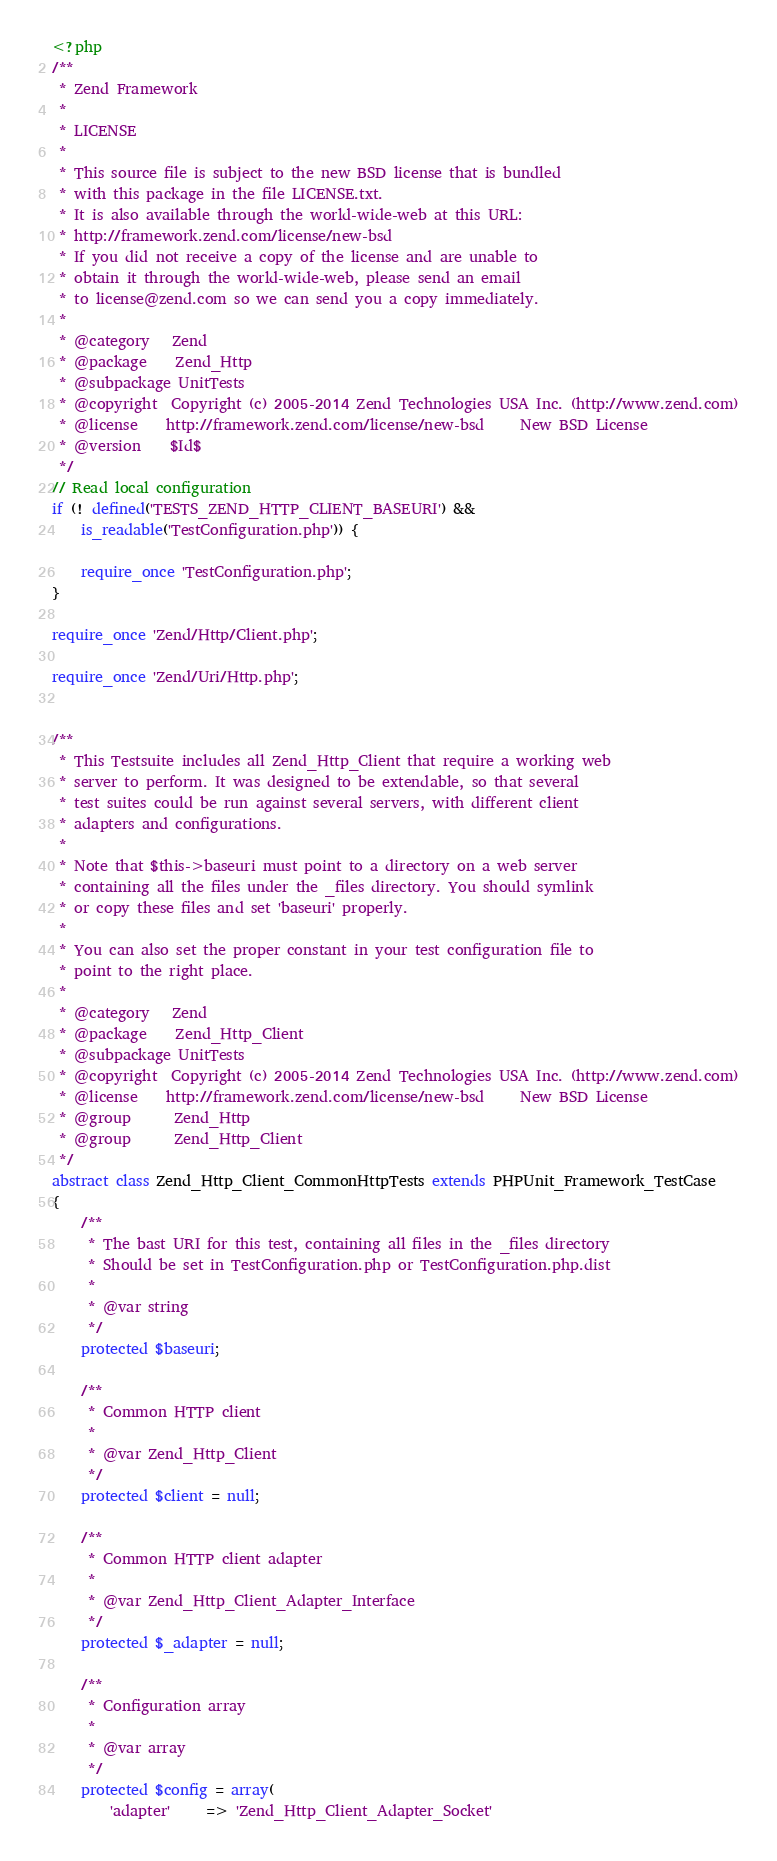Convert code to text. <code><loc_0><loc_0><loc_500><loc_500><_PHP_><?php
/**
 * Zend Framework
 *
 * LICENSE
 *
 * This source file is subject to the new BSD license that is bundled
 * with this package in the file LICENSE.txt.
 * It is also available through the world-wide-web at this URL:
 * http://framework.zend.com/license/new-bsd
 * If you did not receive a copy of the license and are unable to
 * obtain it through the world-wide-web, please send an email
 * to license@zend.com so we can send you a copy immediately.
 *
 * @category   Zend
 * @package    Zend_Http
 * @subpackage UnitTests
 * @copyright  Copyright (c) 2005-2014 Zend Technologies USA Inc. (http://www.zend.com)
 * @license    http://framework.zend.com/license/new-bsd     New BSD License
 * @version    $Id$
 */
// Read local configuration
if (! defined('TESTS_ZEND_HTTP_CLIENT_BASEURI') &&
    is_readable('TestConfiguration.php')) {

    require_once 'TestConfiguration.php';
}

require_once 'Zend/Http/Client.php';

require_once 'Zend/Uri/Http.php';


/**
 * This Testsuite includes all Zend_Http_Client that require a working web
 * server to perform. It was designed to be extendable, so that several
 * test suites could be run against several servers, with different client
 * adapters and configurations.
 *
 * Note that $this->baseuri must point to a directory on a web server
 * containing all the files under the _files directory. You should symlink
 * or copy these files and set 'baseuri' properly.
 *
 * You can also set the proper constant in your test configuration file to
 * point to the right place.
 *
 * @category   Zend
 * @package    Zend_Http_Client
 * @subpackage UnitTests
 * @copyright  Copyright (c) 2005-2014 Zend Technologies USA Inc. (http://www.zend.com)
 * @license    http://framework.zend.com/license/new-bsd     New BSD License
 * @group      Zend_Http
 * @group      Zend_Http_Client
 */
abstract class Zend_Http_Client_CommonHttpTests extends PHPUnit_Framework_TestCase
{
    /**
     * The bast URI for this test, containing all files in the _files directory
     * Should be set in TestConfiguration.php or TestConfiguration.php.dist
     *
     * @var string
     */
    protected $baseuri;

    /**
     * Common HTTP client
     *
     * @var Zend_Http_Client
     */
    protected $client = null;

    /**
     * Common HTTP client adapter
     *
     * @var Zend_Http_Client_Adapter_Interface
     */
    protected $_adapter = null;

    /**
     * Configuration array
     *
     * @var array
     */
    protected $config = array(
        'adapter'     => 'Zend_Http_Client_Adapter_Socket'</code> 